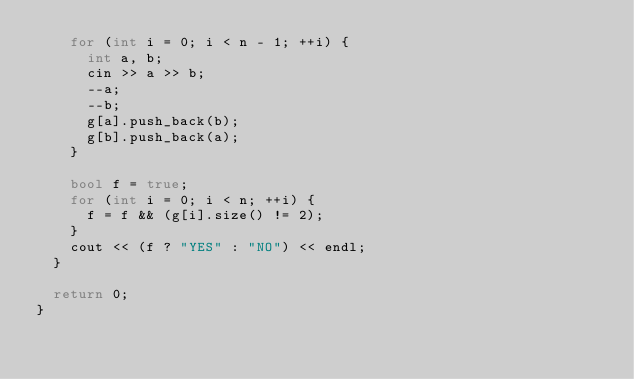Convert code to text. <code><loc_0><loc_0><loc_500><loc_500><_C++_>    for (int i = 0; i < n - 1; ++i) {
      int a, b;
      cin >> a >> b;
      --a;
      --b;
      g[a].push_back(b);
      g[b].push_back(a);
    }

    bool f = true;
    for (int i = 0; i < n; ++i) {
      f = f && (g[i].size() != 2);
    }
    cout << (f ? "YES" : "NO") << endl;
  }

  return 0;
}
</code> 